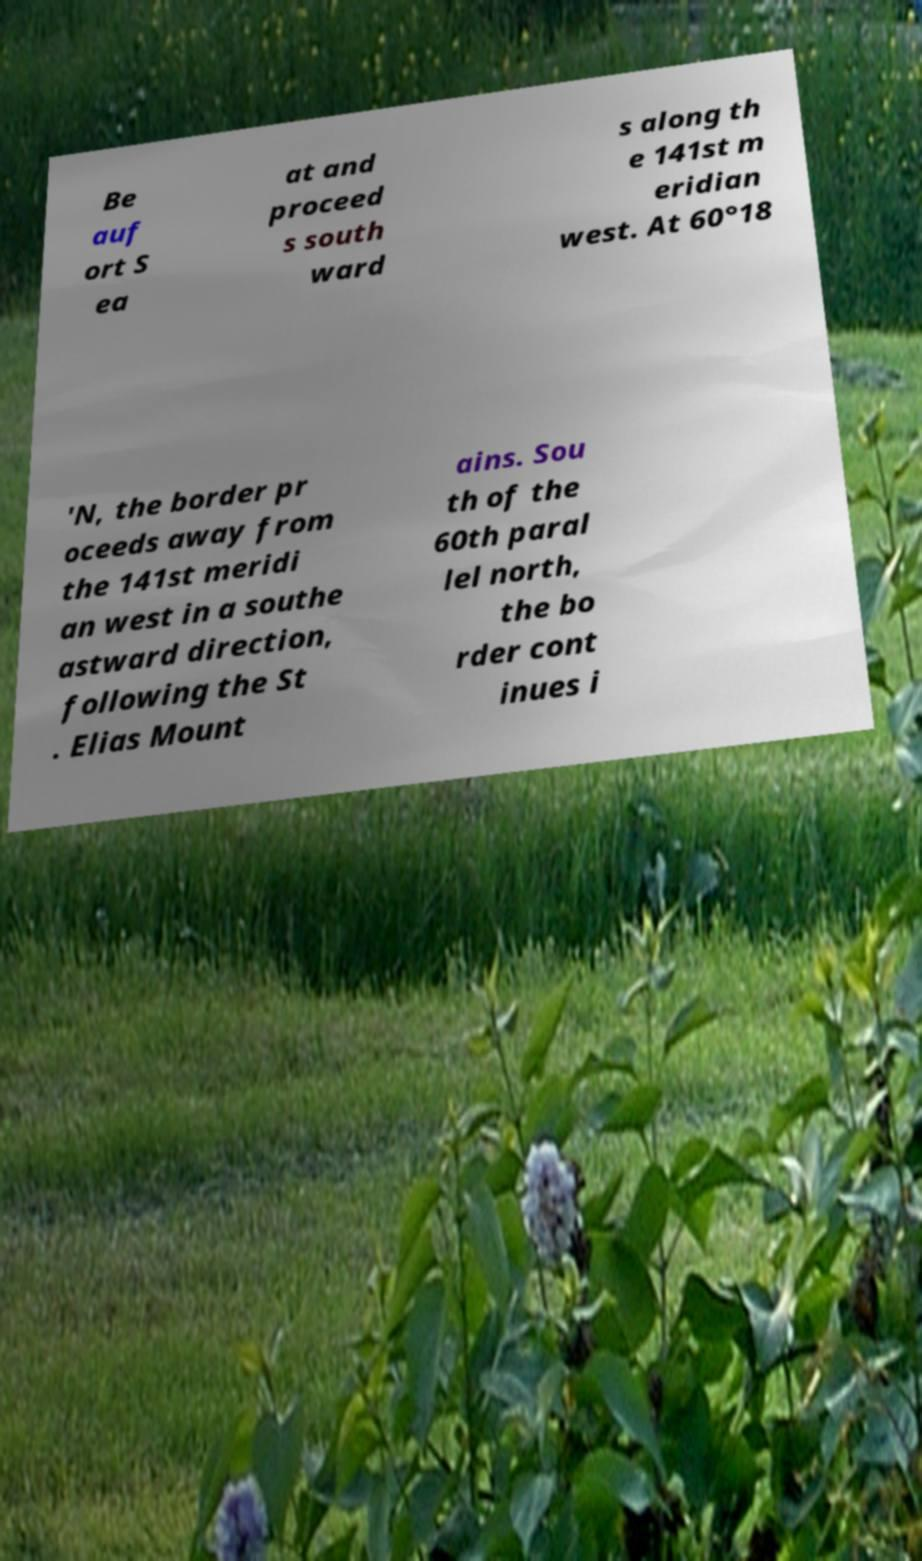Please identify and transcribe the text found in this image. Be auf ort S ea at and proceed s south ward s along th e 141st m eridian west. At 60°18 ′N, the border pr oceeds away from the 141st meridi an west in a southe astward direction, following the St . Elias Mount ains. Sou th of the 60th paral lel north, the bo rder cont inues i 